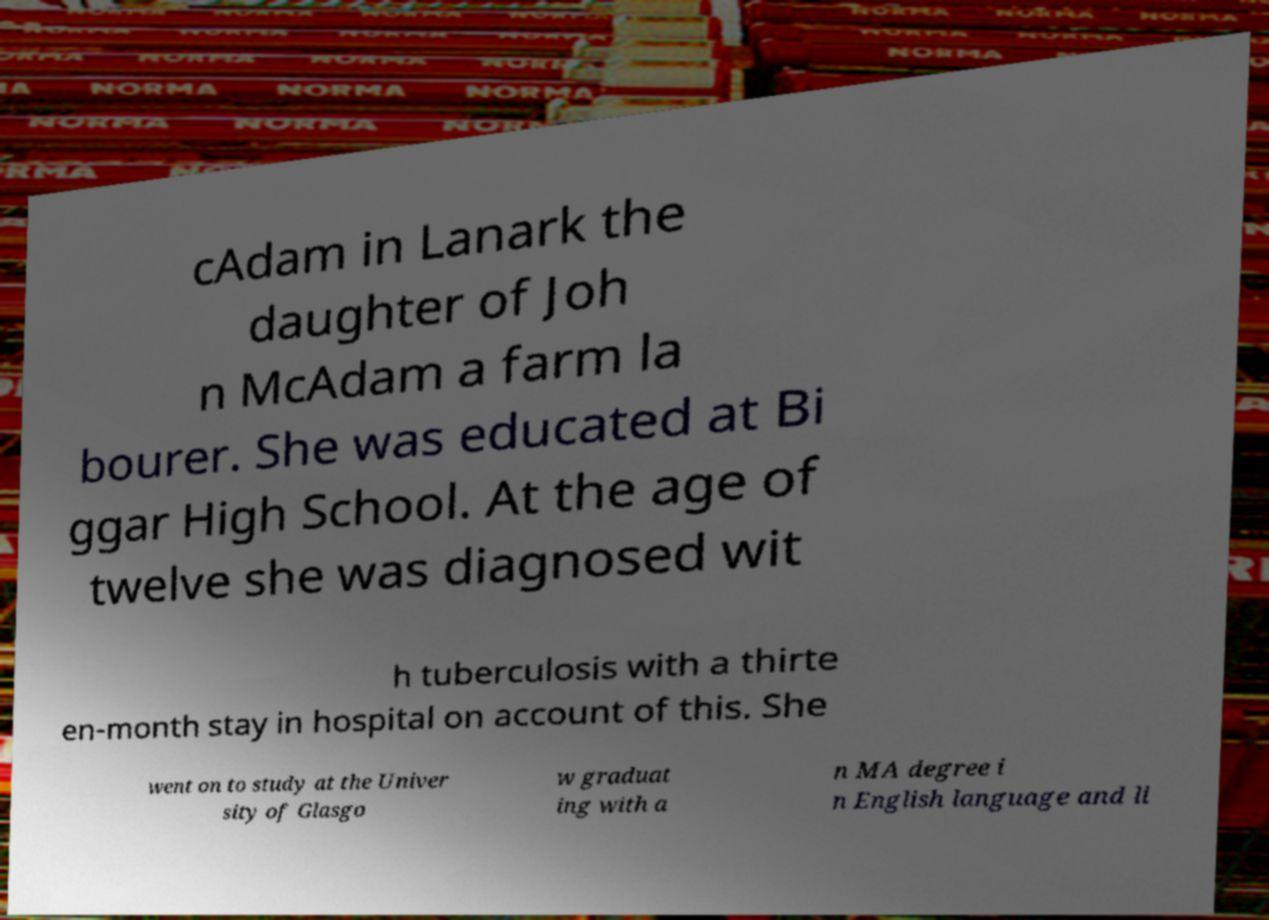Can you read and provide the text displayed in the image?This photo seems to have some interesting text. Can you extract and type it out for me? cAdam in Lanark the daughter of Joh n McAdam a farm la bourer. She was educated at Bi ggar High School. At the age of twelve she was diagnosed wit h tuberculosis with a thirte en-month stay in hospital on account of this. She went on to study at the Univer sity of Glasgo w graduat ing with a n MA degree i n English language and li 